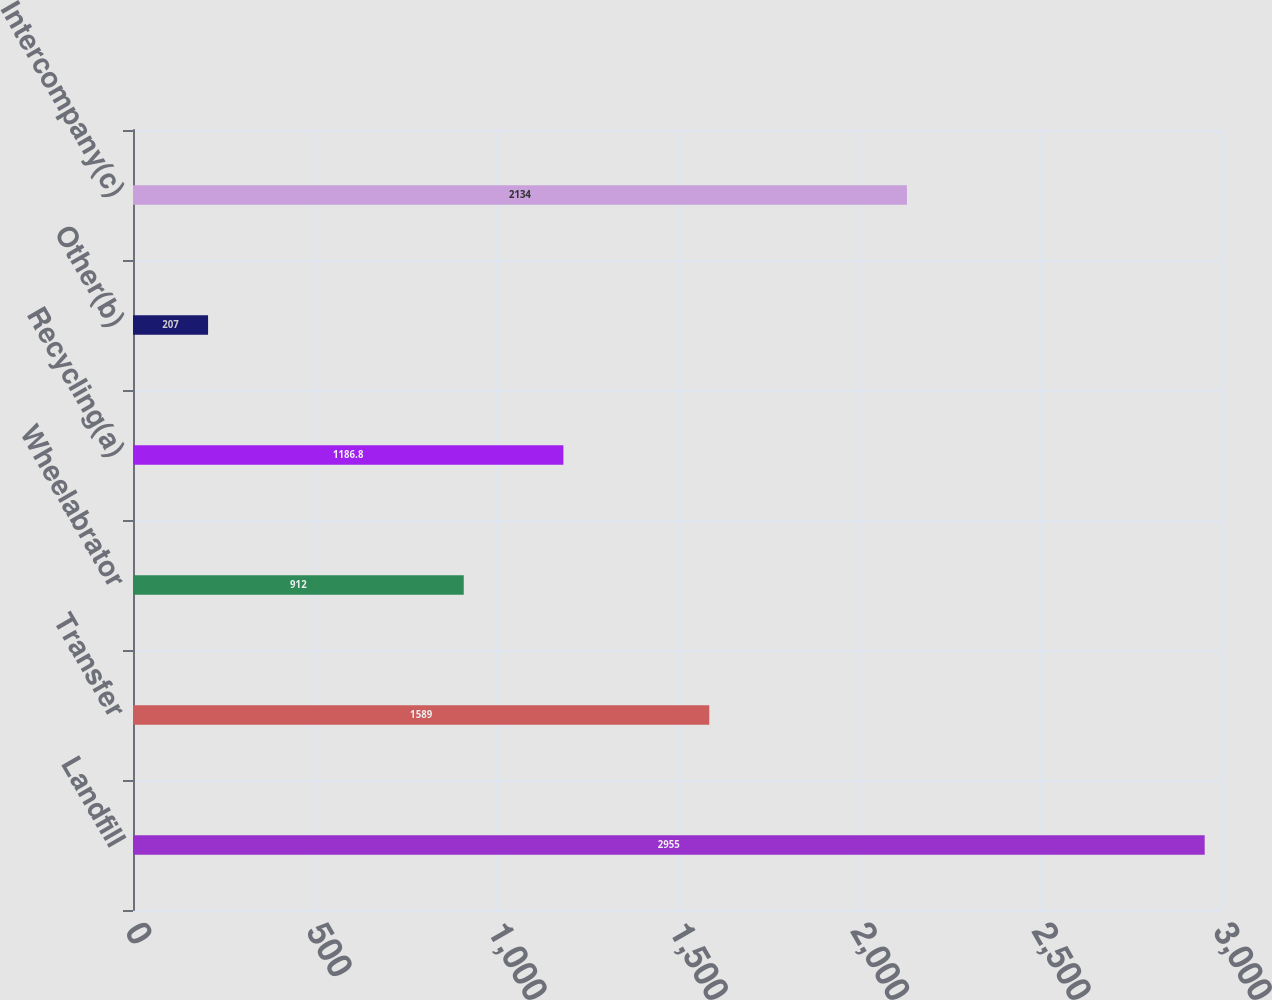<chart> <loc_0><loc_0><loc_500><loc_500><bar_chart><fcel>Landfill<fcel>Transfer<fcel>Wheelabrator<fcel>Recycling(a)<fcel>Other(b)<fcel>Intercompany(c)<nl><fcel>2955<fcel>1589<fcel>912<fcel>1186.8<fcel>207<fcel>2134<nl></chart> 